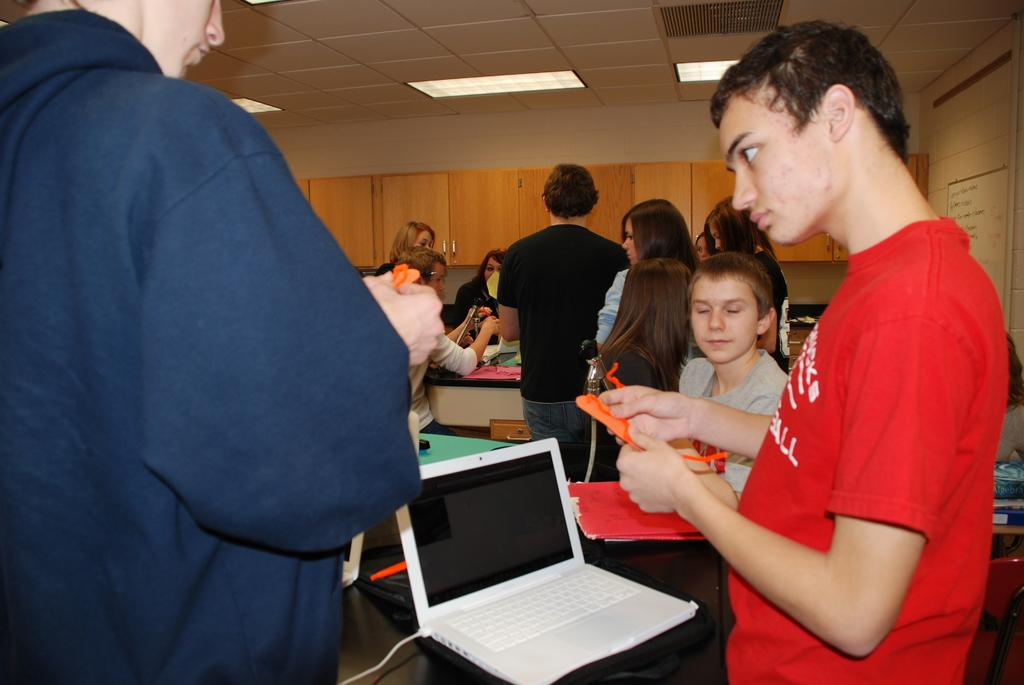How many people are in the image? There is a group of people in the image. What electronic device can be seen in the image? There is a laptop in the image. What equipment is used for amplifying sound in the image? There are microphones (mics) in the image. What type of furniture is present in the image? There are cupboards in the image. What type of lighting is present in the image? There are lights in the image. What other objects can be seen in the image? There are other objects in the image. What can be seen in the background of the image? The walls and the ceiling are visible in the background of the image. What type of roof can be seen in the image? There is no roof visible in the image; only the ceiling is visible in the background. What emotion is the group of people feeling in the image? The image does not convey any specific emotions, so it is impossible to determine how the group of people is feeling. 